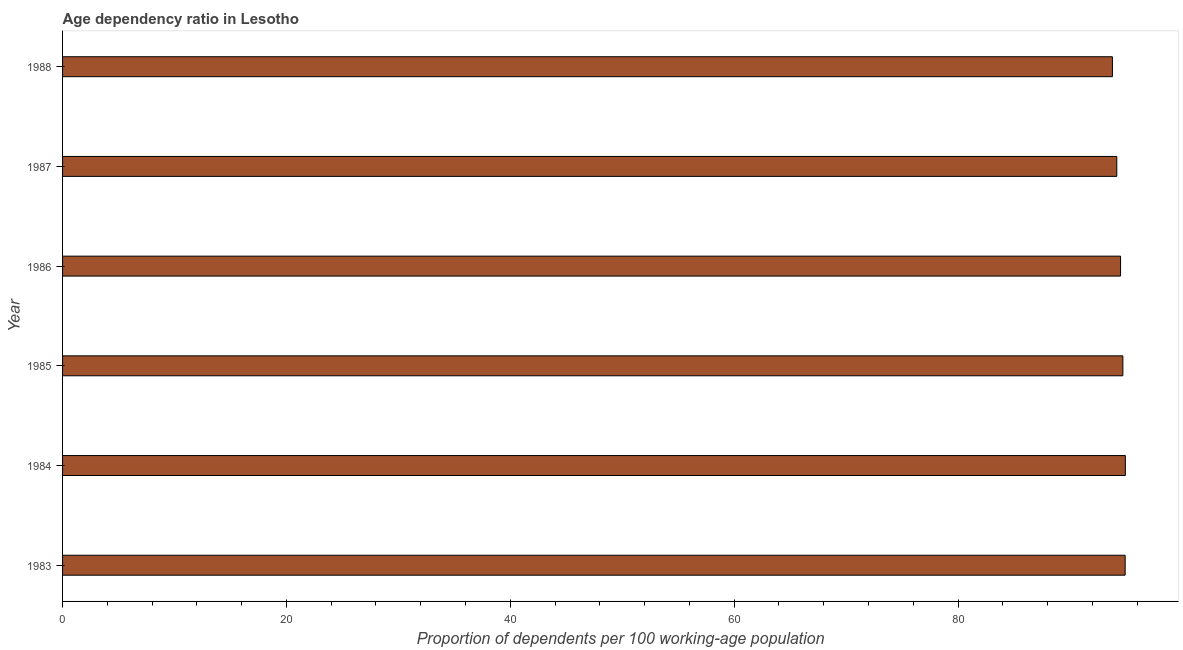Does the graph contain grids?
Provide a succinct answer. No. What is the title of the graph?
Make the answer very short. Age dependency ratio in Lesotho. What is the label or title of the X-axis?
Your answer should be very brief. Proportion of dependents per 100 working-age population. What is the age dependency ratio in 1987?
Offer a terse response. 94.19. Across all years, what is the maximum age dependency ratio?
Give a very brief answer. 94.95. Across all years, what is the minimum age dependency ratio?
Provide a succinct answer. 93.8. In which year was the age dependency ratio maximum?
Your answer should be very brief. 1984. In which year was the age dependency ratio minimum?
Ensure brevity in your answer.  1988. What is the sum of the age dependency ratio?
Your answer should be very brief. 567.11. What is the difference between the age dependency ratio in 1985 and 1986?
Make the answer very short. 0.2. What is the average age dependency ratio per year?
Provide a succinct answer. 94.52. What is the median age dependency ratio?
Keep it short and to the point. 94.62. In how many years, is the age dependency ratio greater than 48 ?
Your answer should be compact. 6. Do a majority of the years between 1986 and 1984 (inclusive) have age dependency ratio greater than 8 ?
Your answer should be very brief. Yes. What is the ratio of the age dependency ratio in 1984 to that in 1985?
Keep it short and to the point. 1. Is the difference between the age dependency ratio in 1985 and 1986 greater than the difference between any two years?
Provide a succinct answer. No. What is the difference between the highest and the second highest age dependency ratio?
Provide a short and direct response. 0.02. What is the difference between the highest and the lowest age dependency ratio?
Provide a succinct answer. 1.15. Are all the bars in the graph horizontal?
Give a very brief answer. Yes. How many years are there in the graph?
Offer a very short reply. 6. What is the Proportion of dependents per 100 working-age population of 1983?
Your answer should be very brief. 94.93. What is the Proportion of dependents per 100 working-age population of 1984?
Your answer should be compact. 94.95. What is the Proportion of dependents per 100 working-age population in 1985?
Provide a short and direct response. 94.73. What is the Proportion of dependents per 100 working-age population in 1986?
Keep it short and to the point. 94.52. What is the Proportion of dependents per 100 working-age population in 1987?
Offer a terse response. 94.19. What is the Proportion of dependents per 100 working-age population of 1988?
Offer a very short reply. 93.8. What is the difference between the Proportion of dependents per 100 working-age population in 1983 and 1984?
Keep it short and to the point. -0.02. What is the difference between the Proportion of dependents per 100 working-age population in 1983 and 1985?
Offer a terse response. 0.21. What is the difference between the Proportion of dependents per 100 working-age population in 1983 and 1986?
Ensure brevity in your answer.  0.41. What is the difference between the Proportion of dependents per 100 working-age population in 1983 and 1987?
Offer a very short reply. 0.75. What is the difference between the Proportion of dependents per 100 working-age population in 1983 and 1988?
Your answer should be compact. 1.14. What is the difference between the Proportion of dependents per 100 working-age population in 1984 and 1985?
Offer a very short reply. 0.22. What is the difference between the Proportion of dependents per 100 working-age population in 1984 and 1986?
Make the answer very short. 0.43. What is the difference between the Proportion of dependents per 100 working-age population in 1984 and 1987?
Offer a terse response. 0.76. What is the difference between the Proportion of dependents per 100 working-age population in 1984 and 1988?
Ensure brevity in your answer.  1.15. What is the difference between the Proportion of dependents per 100 working-age population in 1985 and 1986?
Your answer should be very brief. 0.2. What is the difference between the Proportion of dependents per 100 working-age population in 1985 and 1987?
Your response must be concise. 0.54. What is the difference between the Proportion of dependents per 100 working-age population in 1985 and 1988?
Your response must be concise. 0.93. What is the difference between the Proportion of dependents per 100 working-age population in 1986 and 1987?
Make the answer very short. 0.34. What is the difference between the Proportion of dependents per 100 working-age population in 1986 and 1988?
Provide a short and direct response. 0.73. What is the difference between the Proportion of dependents per 100 working-age population in 1987 and 1988?
Keep it short and to the point. 0.39. What is the ratio of the Proportion of dependents per 100 working-age population in 1983 to that in 1985?
Your answer should be compact. 1. What is the ratio of the Proportion of dependents per 100 working-age population in 1983 to that in 1987?
Your answer should be compact. 1.01. What is the ratio of the Proportion of dependents per 100 working-age population in 1983 to that in 1988?
Offer a very short reply. 1.01. What is the ratio of the Proportion of dependents per 100 working-age population in 1984 to that in 1988?
Give a very brief answer. 1.01. What is the ratio of the Proportion of dependents per 100 working-age population in 1985 to that in 1986?
Ensure brevity in your answer.  1. What is the ratio of the Proportion of dependents per 100 working-age population in 1985 to that in 1987?
Your response must be concise. 1.01. What is the ratio of the Proportion of dependents per 100 working-age population in 1986 to that in 1987?
Keep it short and to the point. 1. 